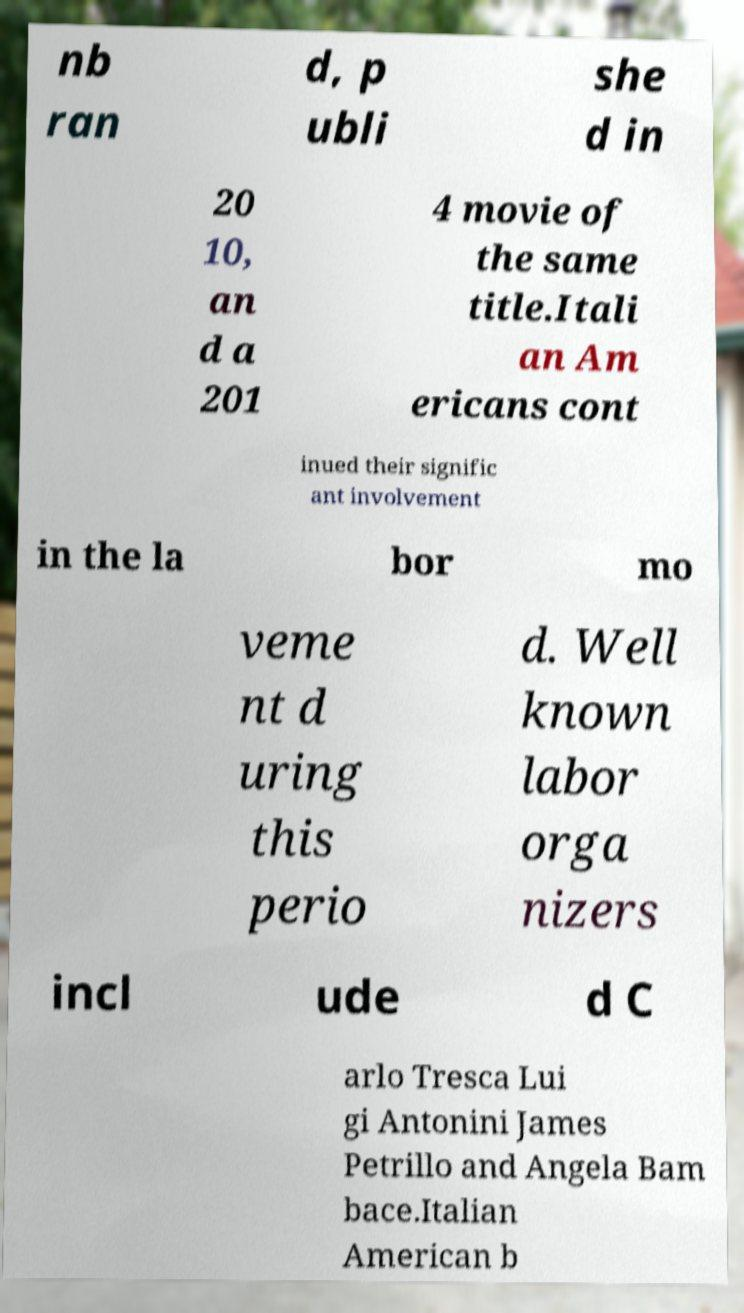Please read and relay the text visible in this image. What does it say? nb ran d, p ubli she d in 20 10, an d a 201 4 movie of the same title.Itali an Am ericans cont inued their signific ant involvement in the la bor mo veme nt d uring this perio d. Well known labor orga nizers incl ude d C arlo Tresca Lui gi Antonini James Petrillo and Angela Bam bace.Italian American b 